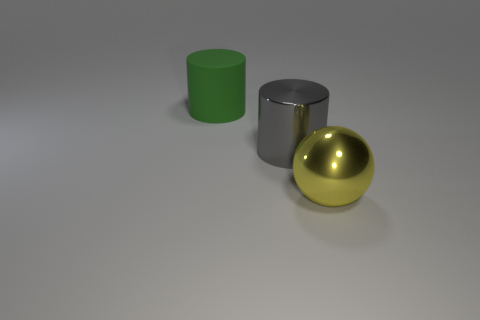Is there anything else that has the same material as the big green thing?
Offer a very short reply. No. Are there any other things that have the same shape as the large yellow object?
Keep it short and to the point. No. What number of large objects have the same material as the green cylinder?
Your answer should be very brief. 0. Is the number of large gray metal objects less than the number of big red rubber balls?
Keep it short and to the point. No. Is the material of the thing right of the big gray cylinder the same as the big gray cylinder?
Offer a very short reply. Yes. Does the big green thing have the same shape as the large gray object?
Make the answer very short. Yes. How many things are things on the left side of the gray thing or gray shiny cylinders?
Your answer should be compact. 2. What number of large objects are gray things or metallic things?
Your response must be concise. 2. Is there a green cylinder made of the same material as the big yellow object?
Your answer should be compact. No. There is a cylinder on the right side of the green rubber cylinder; what is its material?
Provide a succinct answer. Metal. 